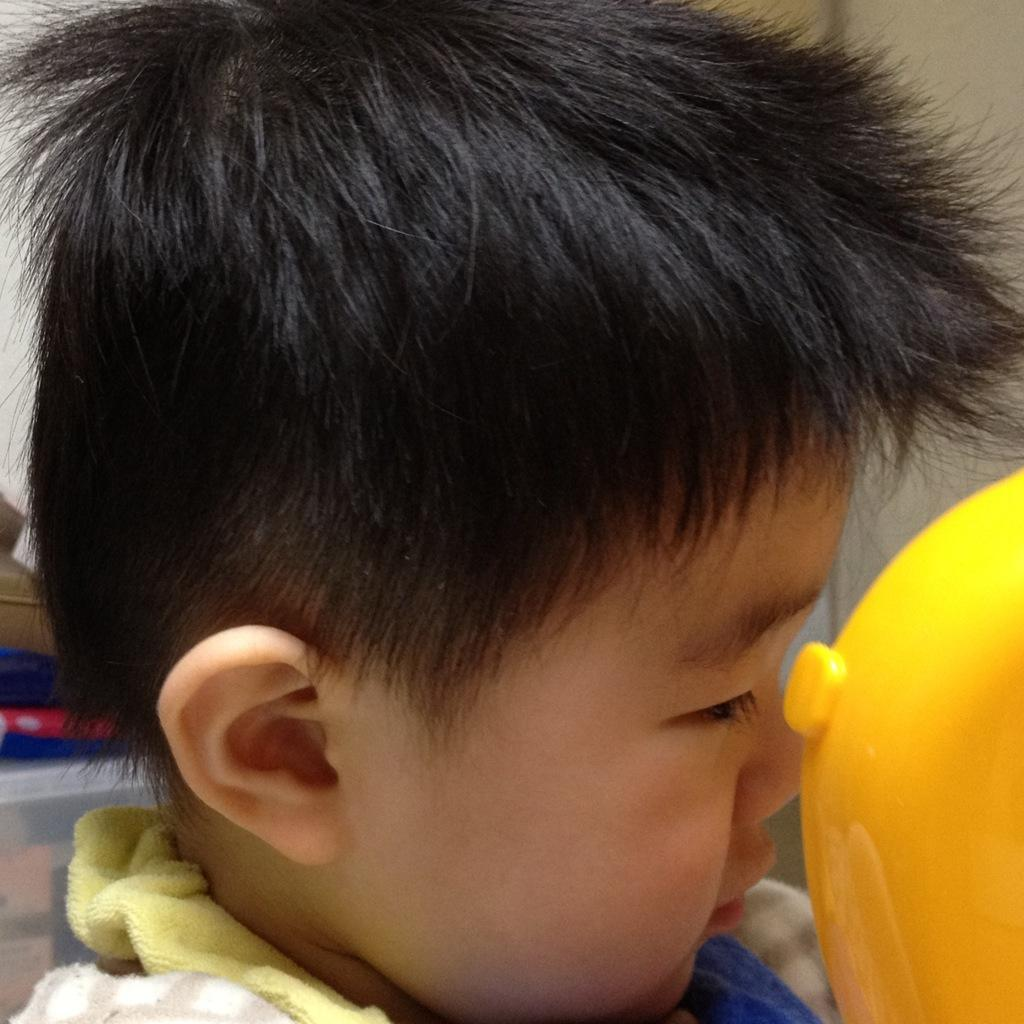Who is present in the image? There is a boy in the image. What color is the object in the image? There is a yellow object in the image. What type of item is yellow in the image? There is a yellow cloth in the image. How many trees can be seen in the image? There are no trees visible in the image. What type of steam is coming from the yellow object in the image? There is no steam present in the image, and the yellow object is a cloth, not an object that would produce steam. 